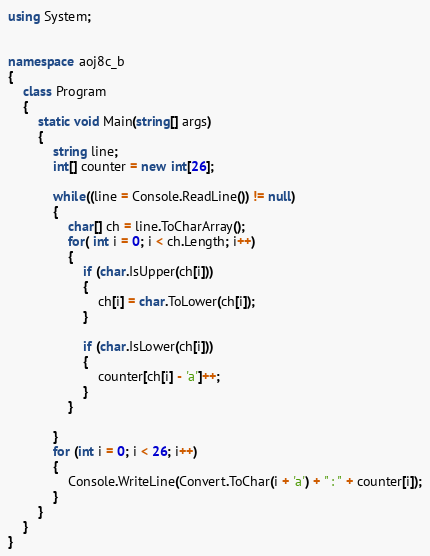Convert code to text. <code><loc_0><loc_0><loc_500><loc_500><_C#_>using System;


namespace aoj8c_b
{
    class Program
    {
        static void Main(string[] args)
        {
            string line;
            int[] counter = new int[26];

            while((line = Console.ReadLine()) != null)
            {
                char[] ch = line.ToCharArray();
                for( int i = 0; i < ch.Length; i++)
                {                   
                    if (char.IsUpper(ch[i]))
                    {
                        ch[i] = char.ToLower(ch[i]);
                    }

                    if (char.IsLower(ch[i]))
                    {
                        counter[ch[i] - 'a']++;
                    }
                }
                
            }
            for (int i = 0; i < 26; i++)
            {
                Console.WriteLine(Convert.ToChar(i + 'a') + " : " + counter[i]);
            }
        }
    }
}</code> 